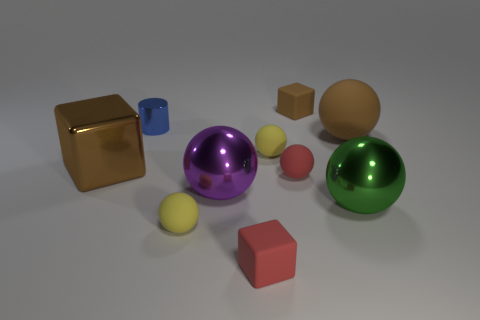Is there a red cube that is right of the small red matte thing that is behind the big green metal object?
Offer a terse response. No. There is a large rubber object that is the same shape as the green metal object; what color is it?
Your answer should be compact. Brown. Are there any other things that have the same shape as the small metallic object?
Offer a terse response. No. What is the color of the ball that is made of the same material as the green object?
Make the answer very short. Purple. There is a sphere behind the tiny yellow rubber sphere that is behind the big green metallic ball; are there any big green shiny spheres that are in front of it?
Offer a very short reply. Yes. Is the number of purple spheres on the left side of the green ball less than the number of tiny yellow spheres right of the tiny red matte cube?
Offer a terse response. No. What number of other balls have the same material as the small red sphere?
Provide a succinct answer. 3. Do the shiny cylinder and the shiny object that is on the left side of the small blue metal object have the same size?
Provide a succinct answer. No. What material is the big cube that is the same color as the big matte object?
Provide a short and direct response. Metal. There is a brown thing that is right of the small matte cube behind the big brown object behind the big brown cube; how big is it?
Make the answer very short. Large. 